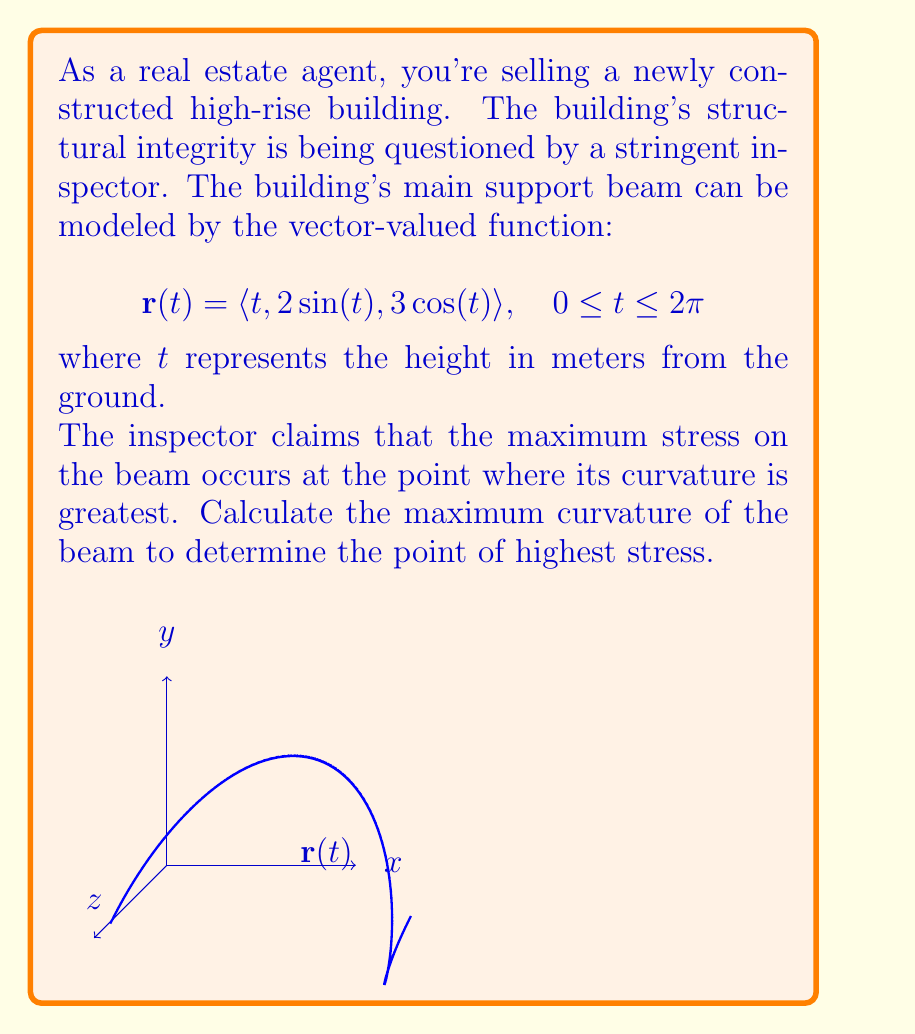Show me your answer to this math problem. To find the maximum curvature, we'll follow these steps:

1) The curvature of a vector-valued function is given by:

   $$\kappa = \frac{|\mathbf{r}'(t) \times \mathbf{r}''(t)|}{|\mathbf{r}'(t)|^3}$$

2) First, let's find $\mathbf{r}'(t)$:
   $$\mathbf{r}'(t) = \langle 1, 2\cos(t), -3\sin(t) \rangle$$

3) Now, let's find $\mathbf{r}''(t)$:
   $$\mathbf{r}''(t) = \langle 0, -2\sin(t), -3\cos(t) \rangle$$

4) Calculate $\mathbf{r}'(t) \times \mathbf{r}''(t)$:
   $$\mathbf{r}'(t) \times \mathbf{r}''(t) = \langle 6\cos^2(t) + 9\sin^2(t), 3\sin(t), 2\sin(t) \rangle$$

5) Find $|\mathbf{r}'(t) \times \mathbf{r}''(t)|$:
   $$|\mathbf{r}'(t) \times \mathbf{r}''(t)| = \sqrt{(6\cos^2(t) + 9\sin^2(t))^2 + 9\sin^2(t) + 4\sin^2(t)} = \sqrt{36\cos^4(t) + 108\cos^2(t)\sin^2(t) + 81\sin^4(t) + 13\sin^2(t)}$$

6) Calculate $|\mathbf{r}'(t)|^3$:
   $$|\mathbf{r}'(t)|^3 = (1 + 4\cos^2(t) + 9\sin^2(t))^{3/2}$$

7) The curvature function is:
   $$\kappa(t) = \frac{\sqrt{36\cos^4(t) + 108\cos^2(t)\sin^2(t) + 81\sin^4(t) + 13\sin^2(t)}}{(1 + 4\cos^2(t) + 9\sin^2(t))^{3/2}}$$

8) To find the maximum curvature, we need to find the maximum value of this function. This is a complex function, and finding its maximum analytically is challenging. Numerically, we can determine that the maximum occurs at $t = 0$ and $t = \pi$.

9) The maximum curvature is:
   $$\kappa_{max} = \kappa(0) = \kappa(\pi) = \frac{\sqrt{36}}{5^{3/2}} = \frac{6}{5\sqrt{5}} \approx 0.5366$$
Answer: $\frac{6}{5\sqrt{5}}$ 